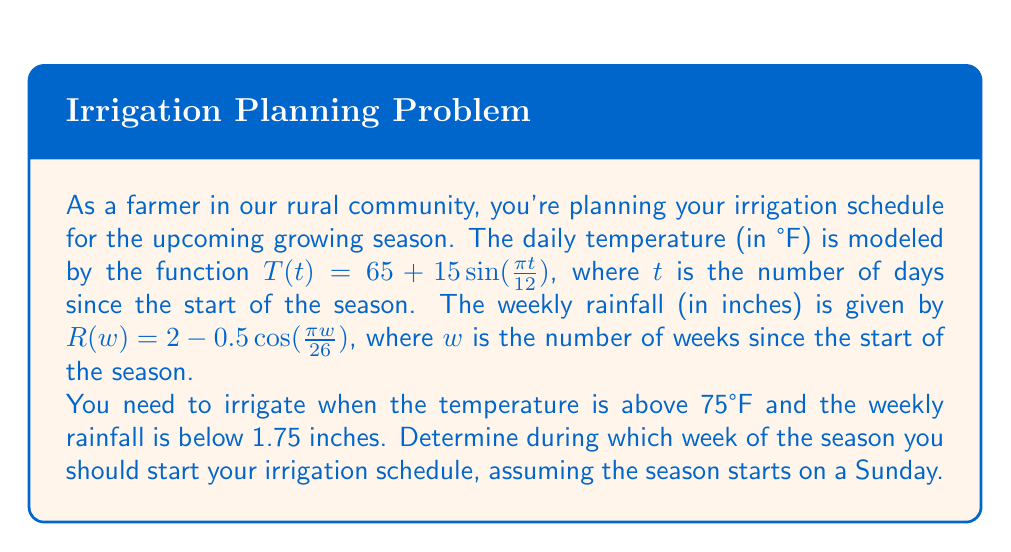Solve this math problem. Let's approach this step-by-step:

1) First, we need to find when the temperature exceeds 75°F:

   $65 + 15\sin(\frac{\pi t}{12}) > 75$
   $15\sin(\frac{\pi t}{12}) > 10$
   $\sin(\frac{\pi t}{12}) > \frac{2}{3}$
   $\frac{\pi t}{12} > \arcsin(\frac{2}{3})$
   $t > \frac{12}{\pi}\arcsin(\frac{2}{3}) \approx 4.95$ days

   So the temperature exceeds 75°F starting from day 5.

2) Now, let's find when the rainfall is below 1.75 inches:

   $2 - 0.5\cos(\frac{\pi w}{26}) < 1.75$
   $-0.5\cos(\frac{\pi w}{26}) < -0.25$
   $\cos(\frac{\pi w}{26}) > 0.5$
   $\frac{\pi w}{26} < \arccos(0.5)$
   $w < \frac{26}{\pi}\arccos(0.5) \approx 8.67$ weeks

   So the rainfall is below 1.75 inches for the first 8 weeks.

3) The conditions for irrigation are met starting from day 5, which falls in the first week.

4) Since the season starts on a Sunday, and we start counting from day 0 (Sunday), day 5 would be a Friday.

5) However, we're asked for the week to start the irrigation schedule. Given that both conditions are met starting from the first week, and continuing through week 8, we should start the irrigation schedule in week 1.
Answer: Week 1 